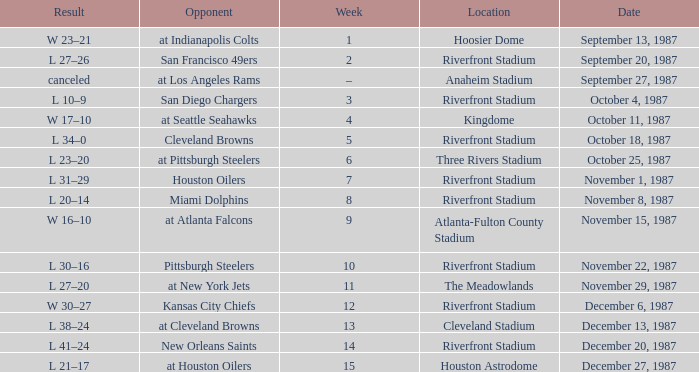What was the result of the game at the Riverfront Stadium after week 8? L 20–14. 